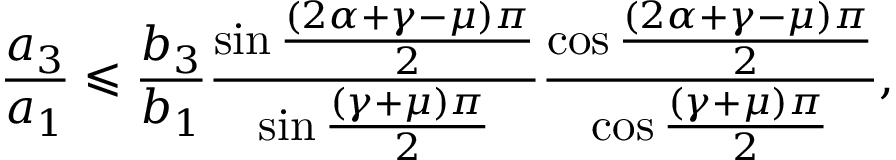<formula> <loc_0><loc_0><loc_500><loc_500>\frac { a _ { 3 } } { a _ { 1 } } \leqslant \frac { b _ { 3 } } { b _ { 1 } } \frac { \sin \frac { \left ( 2 \alpha + \gamma - \mu \right ) \pi } { 2 } } { \sin \frac { \left ( \gamma + \mu \right ) \pi } { 2 } } \frac { \cos \frac { \left ( 2 \alpha + \gamma - \mu \right ) \pi } { 2 } } { \cos \frac { \left ( \gamma + \mu \right ) \pi } { 2 } } ,</formula> 